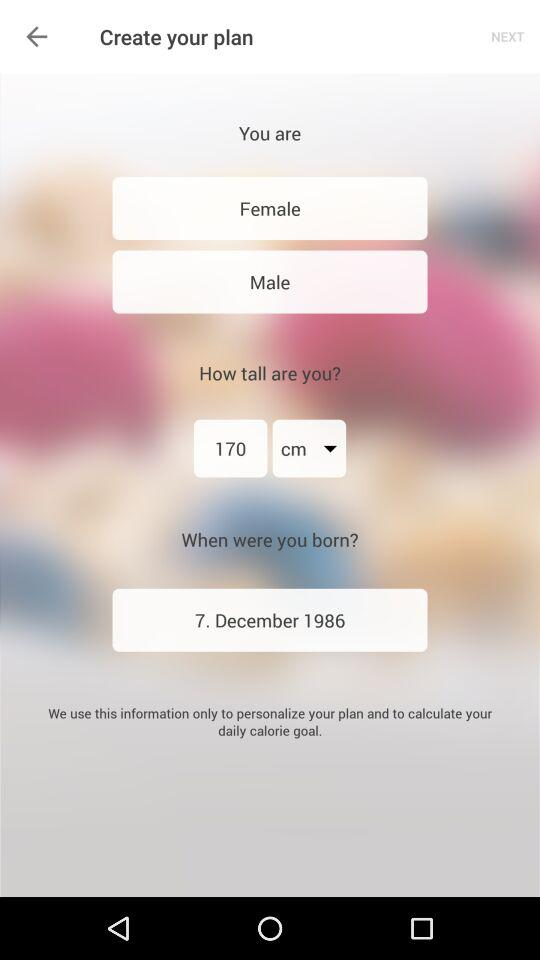What is the date of birth? The date of birth is December 7, 1986. 